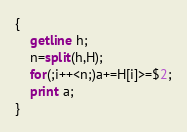<code> <loc_0><loc_0><loc_500><loc_500><_Awk_>{
    getline h;
    n=split(h,H);
    for(;i++<n;)a+=H[i]>=$2;
    print a;
}</code> 